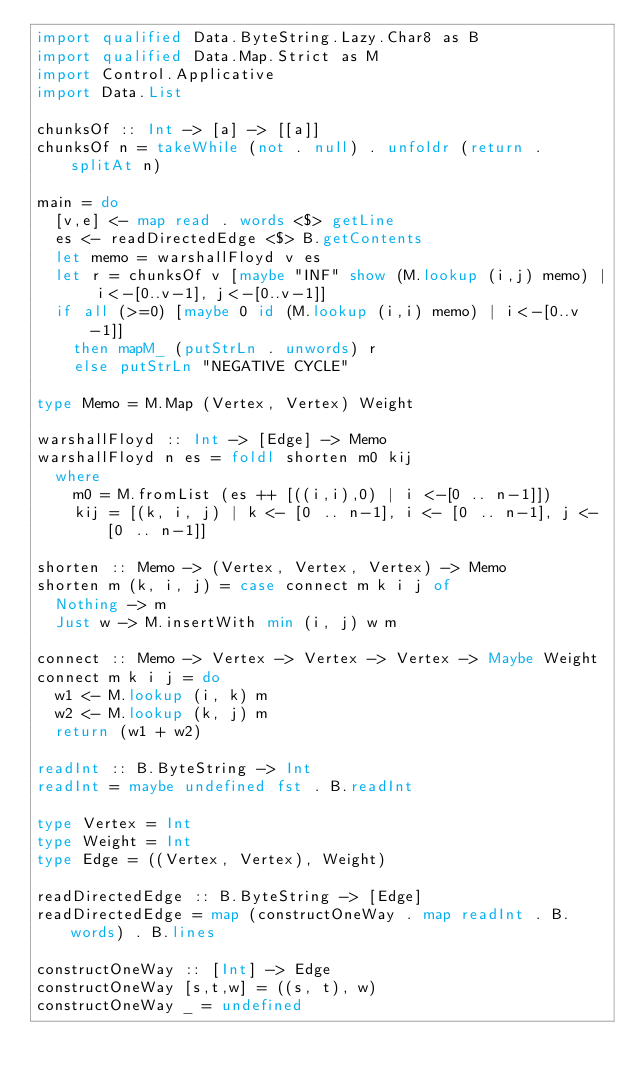Convert code to text. <code><loc_0><loc_0><loc_500><loc_500><_Haskell_>import qualified Data.ByteString.Lazy.Char8 as B
import qualified Data.Map.Strict as M
import Control.Applicative
import Data.List

chunksOf :: Int -> [a] -> [[a]]
chunksOf n = takeWhile (not . null) . unfoldr (return . splitAt n)

main = do
  [v,e] <- map read . words <$> getLine
  es <- readDirectedEdge <$> B.getContents
  let memo = warshallFloyd v es
  let r = chunksOf v [maybe "INF" show (M.lookup (i,j) memo) | i<-[0..v-1], j<-[0..v-1]]
  if all (>=0) [maybe 0 id (M.lookup (i,i) memo) | i<-[0..v-1]]
    then mapM_ (putStrLn . unwords) r
    else putStrLn "NEGATIVE CYCLE"

type Memo = M.Map (Vertex, Vertex) Weight

warshallFloyd :: Int -> [Edge] -> Memo
warshallFloyd n es = foldl shorten m0 kij
  where
    m0 = M.fromList (es ++ [((i,i),0) | i <-[0 .. n-1]])
    kij = [(k, i, j) | k <- [0 .. n-1], i <- [0 .. n-1], j <- [0 .. n-1]]

shorten :: Memo -> (Vertex, Vertex, Vertex) -> Memo
shorten m (k, i, j) = case connect m k i j of
  Nothing -> m
  Just w -> M.insertWith min (i, j) w m

connect :: Memo -> Vertex -> Vertex -> Vertex -> Maybe Weight
connect m k i j = do
  w1 <- M.lookup (i, k) m
  w2 <- M.lookup (k, j) m
  return (w1 + w2)

readInt :: B.ByteString -> Int
readInt = maybe undefined fst . B.readInt

type Vertex = Int
type Weight = Int
type Edge = ((Vertex, Vertex), Weight)

readDirectedEdge :: B.ByteString -> [Edge]
readDirectedEdge = map (constructOneWay . map readInt . B.words) . B.lines

constructOneWay :: [Int] -> Edge
constructOneWay [s,t,w] = ((s, t), w)
constructOneWay _ = undefined</code> 